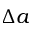<formula> <loc_0><loc_0><loc_500><loc_500>\Delta a</formula> 